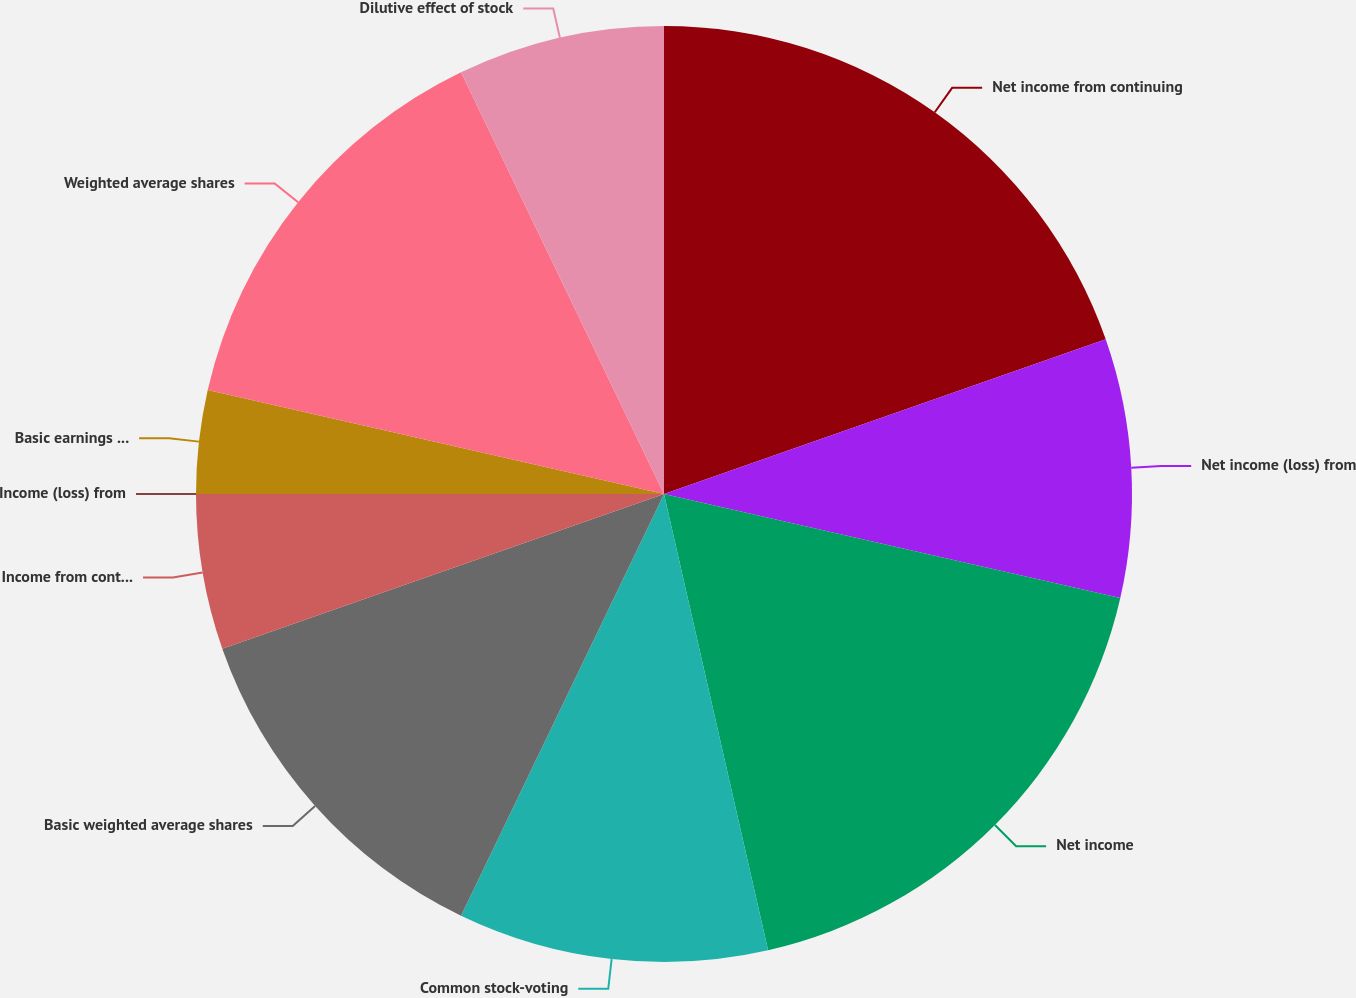Convert chart to OTSL. <chart><loc_0><loc_0><loc_500><loc_500><pie_chart><fcel>Net income from continuing<fcel>Net income (loss) from<fcel>Net income<fcel>Common stock-voting<fcel>Basic weighted average shares<fcel>Income from continuing<fcel>Income (loss) from<fcel>Basic earnings per share<fcel>Weighted average shares<fcel>Dilutive effect of stock<nl><fcel>19.64%<fcel>8.93%<fcel>17.86%<fcel>10.71%<fcel>12.5%<fcel>5.36%<fcel>0.0%<fcel>3.57%<fcel>14.29%<fcel>7.14%<nl></chart> 